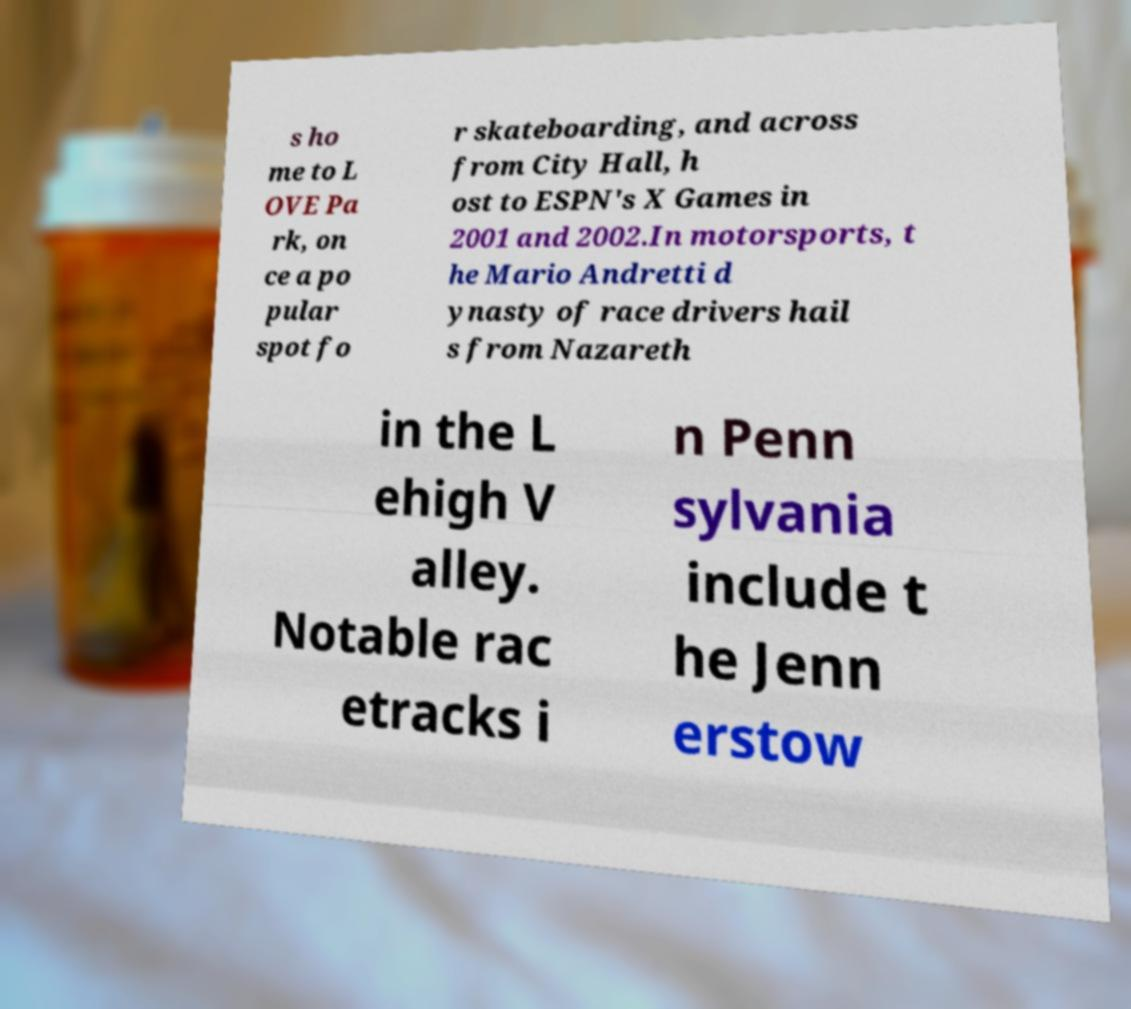I need the written content from this picture converted into text. Can you do that? s ho me to L OVE Pa rk, on ce a po pular spot fo r skateboarding, and across from City Hall, h ost to ESPN's X Games in 2001 and 2002.In motorsports, t he Mario Andretti d ynasty of race drivers hail s from Nazareth in the L ehigh V alley. Notable rac etracks i n Penn sylvania include t he Jenn erstow 